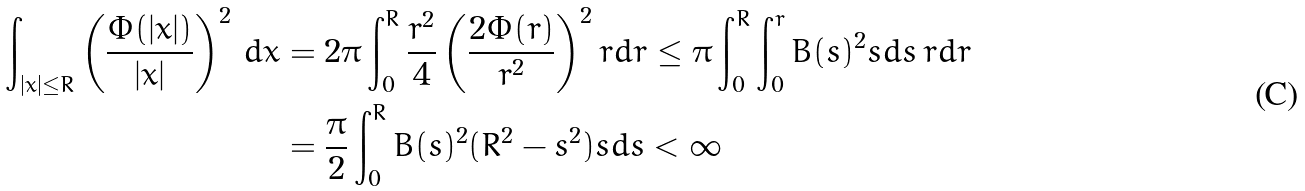Convert formula to latex. <formula><loc_0><loc_0><loc_500><loc_500>\int _ { | x | \leq R } \left ( \frac { \Phi ( | x | ) } { | x | } \right ) ^ { 2 } \, d x & = 2 \pi \int _ { 0 } ^ { R } \frac { r ^ { 2 } } { 4 } \left ( \frac { 2 \Phi ( r ) } { r ^ { 2 } } \right ) ^ { 2 } r d r \leq \pi \int _ { 0 } ^ { R } \int _ { 0 } ^ { r } B ( s ) ^ { 2 } s d s \, r d r \\ & = \frac { \pi } { 2 } \int _ { 0 } ^ { R } B ( s ) ^ { 2 } ( R ^ { 2 } - s ^ { 2 } ) s d s < \infty</formula> 